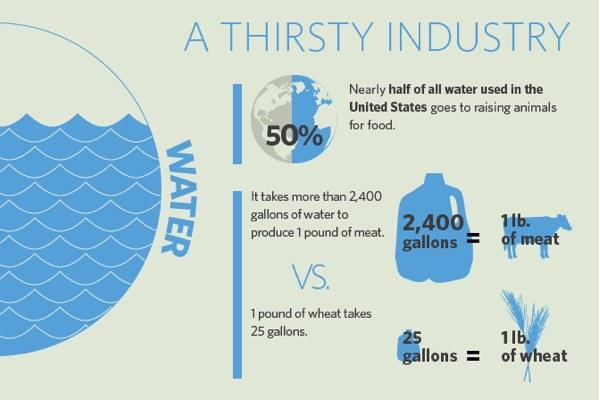How many cows are in this infographic?
Answer the question with a short phrase. 1 